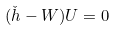Convert formula to latex. <formula><loc_0><loc_0><loc_500><loc_500>( \check { h } - W ) U = 0</formula> 